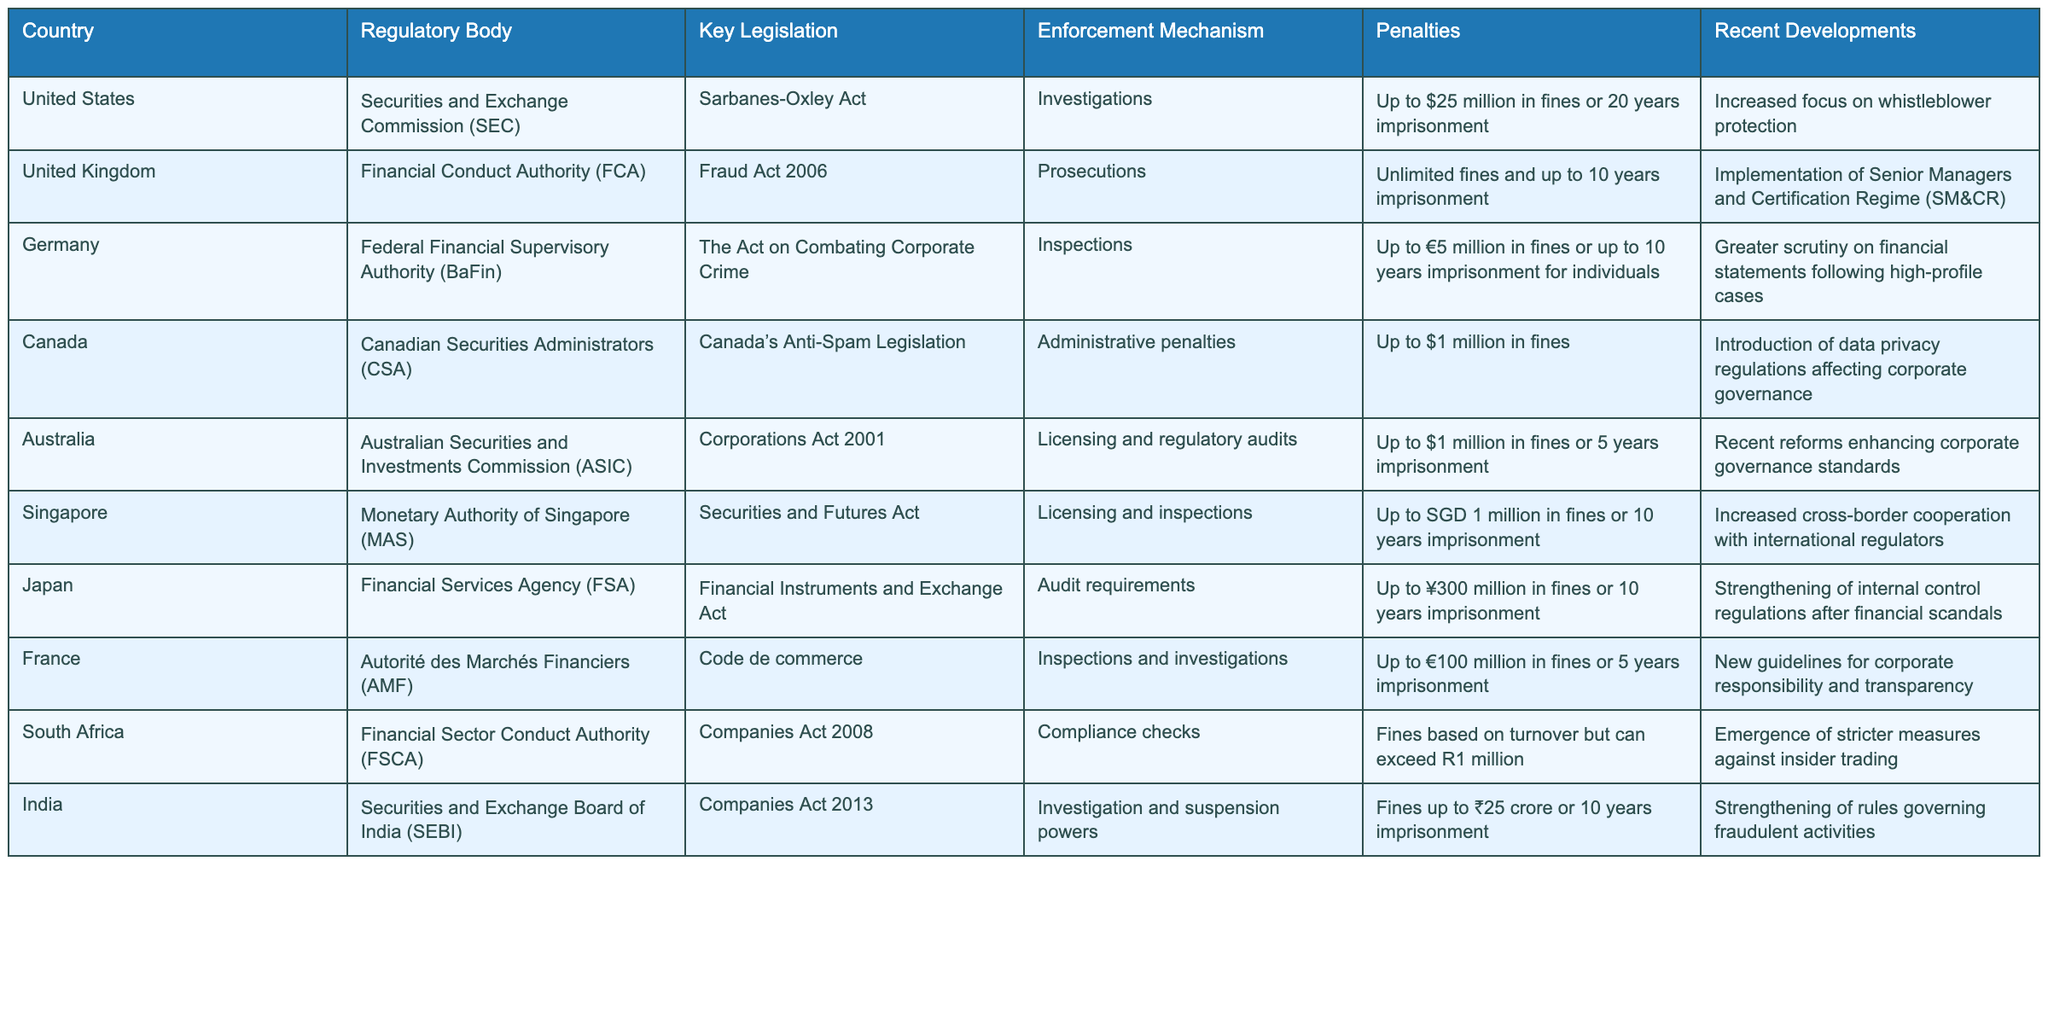What is the key legislation for white-collar crime in Canada? According to the table, the key legislation for white-collar crime in Canada is Canada’s Anti-Spam Legislation.
Answer: Canada’s Anti-Spam Legislation Which country's regulatory body is the Financial Conduct Authority? The table states that the Financial Conduct Authority is in the United Kingdom.
Answer: United Kingdom What are the penalties specified for white-collar crime in Germany? The penalties for white-collar crime in Germany include fines of up to €5 million or up to 10 years imprisonment for individuals.
Answer: Up to €5 million in fines or 10 years imprisonment Is there a country where enforcement against white-collar crime does not involve prosecutions? Yes, Canada does not involve prosecutions as its enforcement mechanism consists of administrative penalties.
Answer: Yes Which two countries have unlimited fines as part of their penalties for white-collar crime? By reviewing the table, France and the United Kingdom both have unlimited fines as part of their penalties for white-collar crime.
Answer: France and United Kingdom What is the most common enforcement mechanism used across the countries listed? The most common enforcement mechanism among the listed countries is inspections, as seen in Germany, France, and Singapore.
Answer: Inspections How does the enforcement mechanism of the United States differ from that of Australia? The United States uses investigations as its enforcement mechanism, whereas Australia relies on licensing and regulatory audits. This shows a difference in their approaches to enforcement processes.
Answer: Investigations (US) vs. Licensing and regulatory audits (Australia) What is the range of possible imprisonment lengths for the penalties across the different countries? By reviewing the penalties, imprisonment ranges from 5 years to 20 years, with specific countries allowing various lengths within that range.
Answer: 5 to 20 years What recent development in the United States emphasizes corporate governance? The recent development in the United States includes an increased focus on whistleblower protection, which seeks to enhance corporate governance practices.
Answer: Increased focus on whistleblower protection 